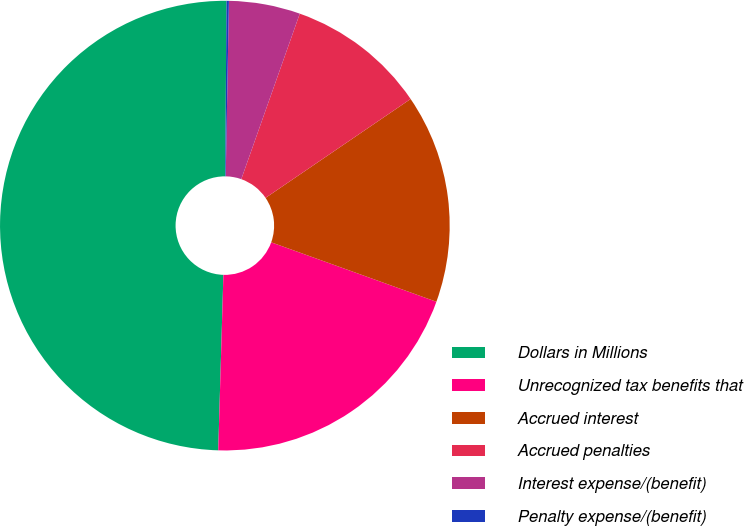<chart> <loc_0><loc_0><loc_500><loc_500><pie_chart><fcel>Dollars in Millions<fcel>Unrecognized tax benefits that<fcel>Accrued interest<fcel>Accrued penalties<fcel>Interest expense/(benefit)<fcel>Penalty expense/(benefit)<nl><fcel>49.65%<fcel>19.97%<fcel>15.02%<fcel>10.07%<fcel>5.12%<fcel>0.17%<nl></chart> 